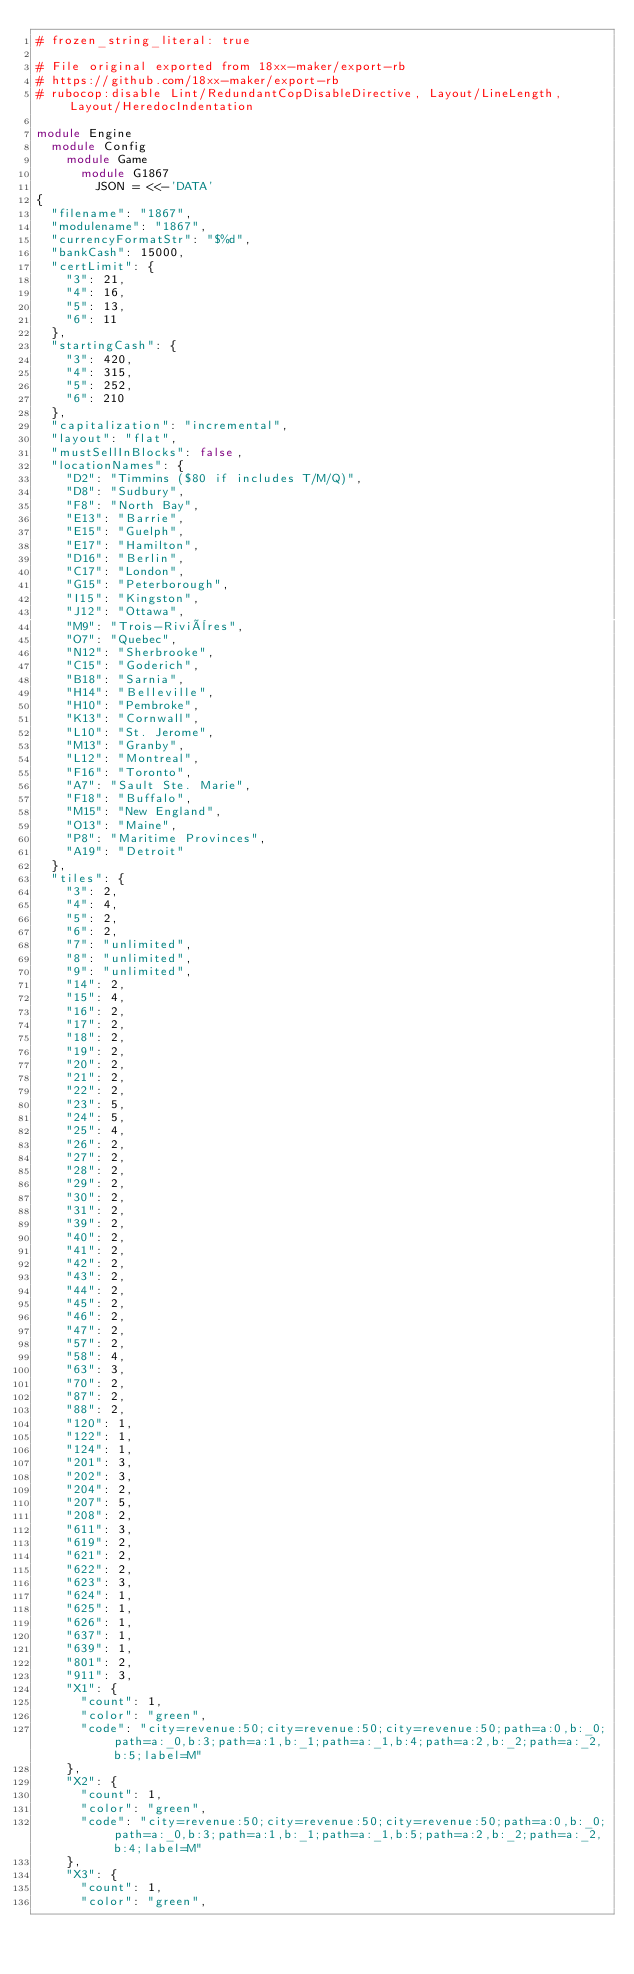Convert code to text. <code><loc_0><loc_0><loc_500><loc_500><_Ruby_># frozen_string_literal: true

# File original exported from 18xx-maker/export-rb
# https://github.com/18xx-maker/export-rb
# rubocop:disable Lint/RedundantCopDisableDirective, Layout/LineLength, Layout/HeredocIndentation

module Engine
  module Config
    module Game
      module G1867
        JSON = <<-'DATA'
{
  "filename": "1867",
  "modulename": "1867",
  "currencyFormatStr": "$%d",
  "bankCash": 15000,
  "certLimit": {
    "3": 21,
    "4": 16,
    "5": 13,
    "6": 11
  },
  "startingCash": {
    "3": 420,
    "4": 315,
    "5": 252,
    "6": 210
  },
  "capitalization": "incremental",
  "layout": "flat",
  "mustSellInBlocks": false,
  "locationNames": {
    "D2": "Timmins ($80 if includes T/M/Q)",
    "D8": "Sudbury",
    "F8": "North Bay",
    "E13": "Barrie",
    "E15": "Guelph",
    "E17": "Hamilton",
    "D16": "Berlin",
    "C17": "London",
    "G15": "Peterborough",
    "I15": "Kingston",
    "J12": "Ottawa",
    "M9": "Trois-Rivières",
    "O7": "Quebec",
    "N12": "Sherbrooke",
    "C15": "Goderich",
    "B18": "Sarnia",
    "H14": "Belleville",
    "H10": "Pembroke",
    "K13": "Cornwall",
    "L10": "St. Jerome",
    "M13": "Granby",
    "L12": "Montreal",
    "F16": "Toronto",
    "A7": "Sault Ste. Marie",
    "F18": "Buffalo",
    "M15": "New England",
    "O13": "Maine",
    "P8": "Maritime Provinces",
    "A19": "Detroit"
  },
  "tiles": {
    "3": 2,
    "4": 4,
    "5": 2,
    "6": 2,
    "7": "unlimited",
    "8": "unlimited",
    "9": "unlimited",
    "14": 2,
    "15": 4,
    "16": 2,
    "17": 2,
    "18": 2,
    "19": 2,
    "20": 2,
    "21": 2,
    "22": 2,
    "23": 5,
    "24": 5,
    "25": 4,
    "26": 2,
    "27": 2,
    "28": 2,
    "29": 2,
    "30": 2,
    "31": 2,
    "39": 2,
    "40": 2,
    "41": 2,
    "42": 2,
    "43": 2,
    "44": 2,
    "45": 2,
    "46": 2,
    "47": 2,
    "57": 2,
    "58": 4,
    "63": 3,
    "70": 2,
    "87": 2,
    "88": 2,
    "120": 1,
    "122": 1,
    "124": 1,
    "201": 3,
    "202": 3,
    "204": 2,
    "207": 5,
    "208": 2,
    "611": 3,
    "619": 2,
    "621": 2,
    "622": 2,
    "623": 3,
    "624": 1,
    "625": 1,
    "626": 1,
    "637": 1,
    "639": 1,
    "801": 2,
    "911": 3,
    "X1": {
      "count": 1,
      "color": "green",
      "code": "city=revenue:50;city=revenue:50;city=revenue:50;path=a:0,b:_0;path=a:_0,b:3;path=a:1,b:_1;path=a:_1,b:4;path=a:2,b:_2;path=a:_2,b:5;label=M"
    },
    "X2": {
      "count": 1,
      "color": "green",
      "code": "city=revenue:50;city=revenue:50;city=revenue:50;path=a:0,b:_0;path=a:_0,b:3;path=a:1,b:_1;path=a:_1,b:5;path=a:2,b:_2;path=a:_2,b:4;label=M"
    },
    "X3": {
      "count": 1,
      "color": "green",</code> 